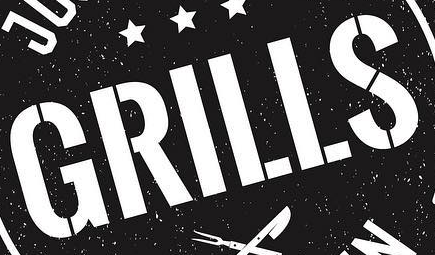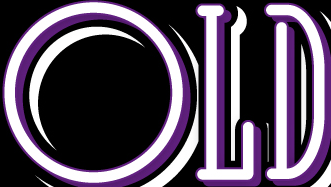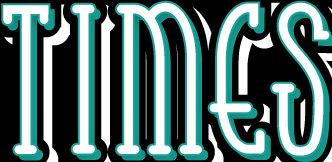Read the text from these images in sequence, separated by a semicolon. GRILLS; OLD; TIMES 